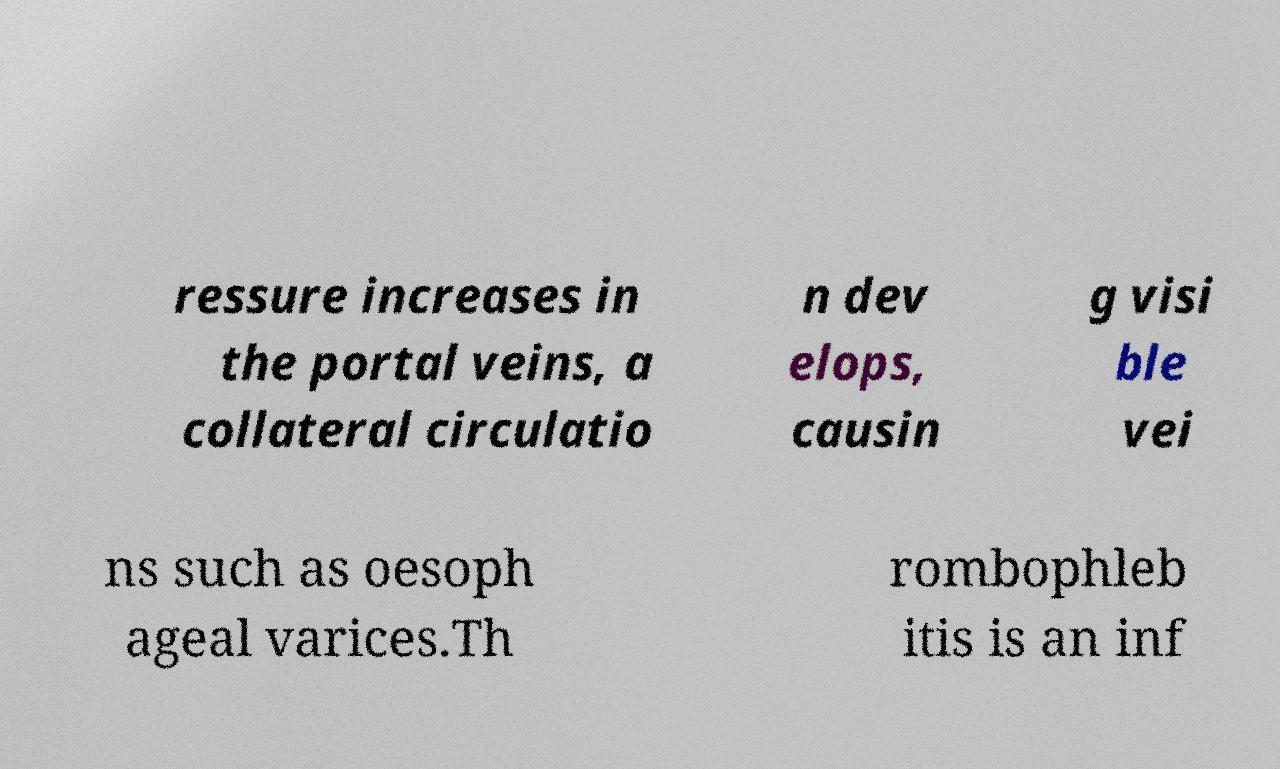Could you extract and type out the text from this image? ressure increases in the portal veins, a collateral circulatio n dev elops, causin g visi ble vei ns such as oesoph ageal varices.Th rombophleb itis is an inf 